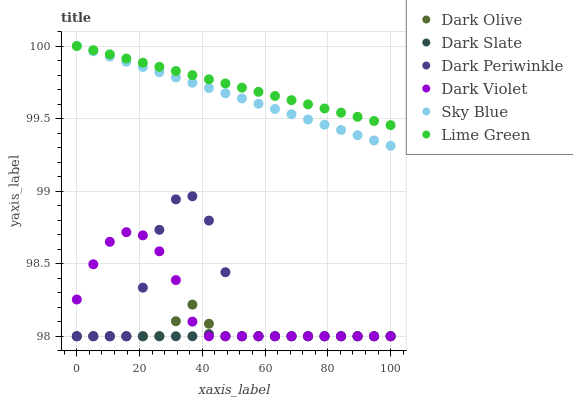Does Dark Slate have the minimum area under the curve?
Answer yes or no. Yes. Does Lime Green have the maximum area under the curve?
Answer yes or no. Yes. Does Dark Violet have the minimum area under the curve?
Answer yes or no. No. Does Dark Violet have the maximum area under the curve?
Answer yes or no. No. Is Sky Blue the smoothest?
Answer yes or no. Yes. Is Dark Periwinkle the roughest?
Answer yes or no. Yes. Is Dark Violet the smoothest?
Answer yes or no. No. Is Dark Violet the roughest?
Answer yes or no. No. Does Dark Olive have the lowest value?
Answer yes or no. Yes. Does Sky Blue have the lowest value?
Answer yes or no. No. Does Lime Green have the highest value?
Answer yes or no. Yes. Does Dark Violet have the highest value?
Answer yes or no. No. Is Dark Periwinkle less than Lime Green?
Answer yes or no. Yes. Is Lime Green greater than Dark Violet?
Answer yes or no. Yes. Does Dark Olive intersect Dark Periwinkle?
Answer yes or no. Yes. Is Dark Olive less than Dark Periwinkle?
Answer yes or no. No. Is Dark Olive greater than Dark Periwinkle?
Answer yes or no. No. Does Dark Periwinkle intersect Lime Green?
Answer yes or no. No. 